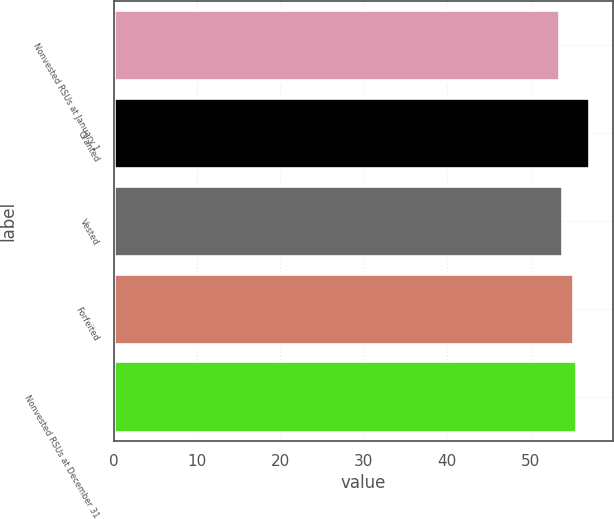Convert chart. <chart><loc_0><loc_0><loc_500><loc_500><bar_chart><fcel>Nonvested RSUs at January 1<fcel>Granted<fcel>Vested<fcel>Forfeited<fcel>Nonvested RSUs at December 31<nl><fcel>53.35<fcel>57.03<fcel>53.72<fcel>55.07<fcel>55.44<nl></chart> 